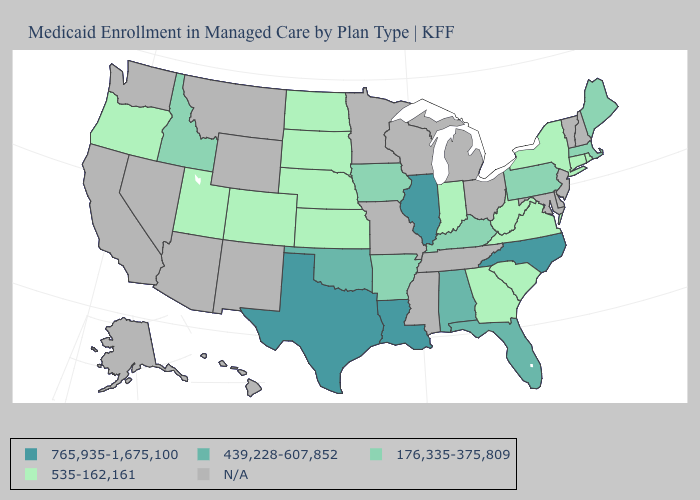How many symbols are there in the legend?
Answer briefly. 5. Name the states that have a value in the range 535-162,161?
Quick response, please. Colorado, Connecticut, Georgia, Indiana, Kansas, Nebraska, New York, North Dakota, Oregon, Rhode Island, South Carolina, South Dakota, Utah, Virginia, West Virginia. How many symbols are there in the legend?
Be succinct. 5. Which states hav the highest value in the West?
Give a very brief answer. Idaho. What is the lowest value in states that border Wisconsin?
Quick response, please. 176,335-375,809. Name the states that have a value in the range 765,935-1,675,100?
Quick response, please. Illinois, Louisiana, North Carolina, Texas. What is the value of Maryland?
Short answer required. N/A. What is the highest value in the USA?
Give a very brief answer. 765,935-1,675,100. What is the highest value in the Northeast ?
Quick response, please. 176,335-375,809. How many symbols are there in the legend?
Write a very short answer. 5. Does the map have missing data?
Give a very brief answer. Yes. What is the value of Connecticut?
Concise answer only. 535-162,161. What is the value of New Jersey?
Be succinct. N/A. What is the value of Georgia?
Be succinct. 535-162,161. 